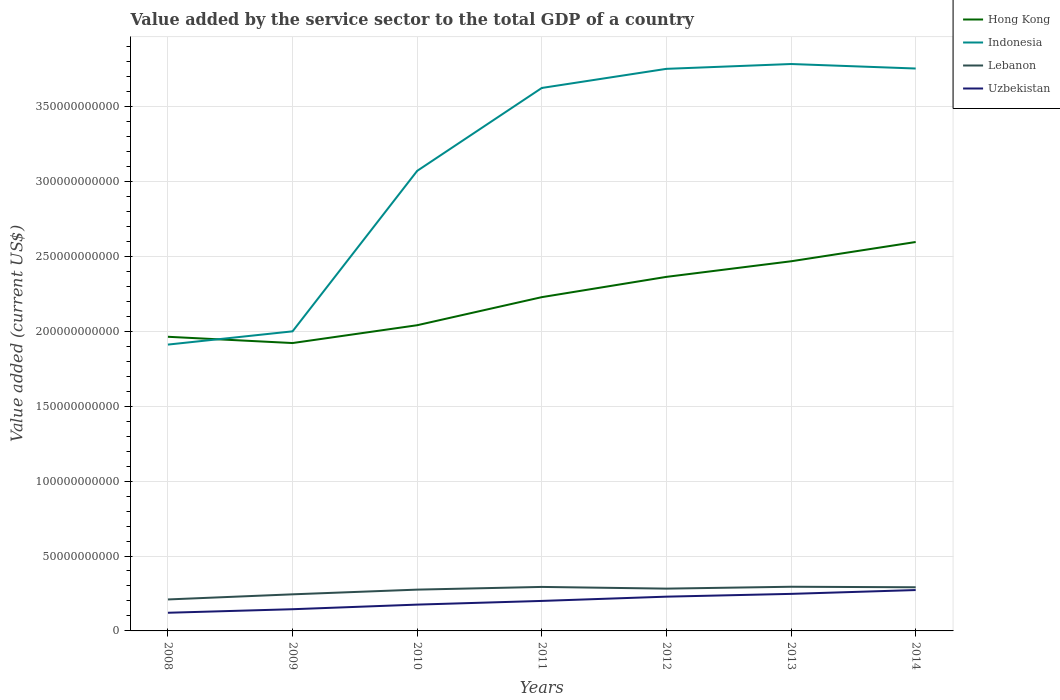Does the line corresponding to Indonesia intersect with the line corresponding to Lebanon?
Your answer should be very brief. No. Is the number of lines equal to the number of legend labels?
Your answer should be compact. Yes. Across all years, what is the maximum value added by the service sector to the total GDP in Indonesia?
Offer a terse response. 1.91e+11. In which year was the value added by the service sector to the total GDP in Lebanon maximum?
Keep it short and to the point. 2008. What is the total value added by the service sector to the total GDP in Lebanon in the graph?
Make the answer very short. -3.41e+09. What is the difference between the highest and the second highest value added by the service sector to the total GDP in Lebanon?
Your answer should be very brief. 8.47e+09. What is the difference between the highest and the lowest value added by the service sector to the total GDP in Lebanon?
Provide a succinct answer. 5. Is the value added by the service sector to the total GDP in Hong Kong strictly greater than the value added by the service sector to the total GDP in Indonesia over the years?
Your answer should be compact. No. How many years are there in the graph?
Provide a short and direct response. 7. What is the difference between two consecutive major ticks on the Y-axis?
Your response must be concise. 5.00e+1. Are the values on the major ticks of Y-axis written in scientific E-notation?
Make the answer very short. No. Does the graph contain grids?
Make the answer very short. Yes. Where does the legend appear in the graph?
Make the answer very short. Top right. How many legend labels are there?
Offer a terse response. 4. What is the title of the graph?
Ensure brevity in your answer.  Value added by the service sector to the total GDP of a country. Does "High income: nonOECD" appear as one of the legend labels in the graph?
Your answer should be very brief. No. What is the label or title of the Y-axis?
Provide a succinct answer. Value added (current US$). What is the Value added (current US$) of Hong Kong in 2008?
Offer a very short reply. 1.96e+11. What is the Value added (current US$) of Indonesia in 2008?
Keep it short and to the point. 1.91e+11. What is the Value added (current US$) in Lebanon in 2008?
Keep it short and to the point. 2.10e+1. What is the Value added (current US$) of Uzbekistan in 2008?
Provide a succinct answer. 1.21e+1. What is the Value added (current US$) of Hong Kong in 2009?
Offer a very short reply. 1.92e+11. What is the Value added (current US$) of Indonesia in 2009?
Ensure brevity in your answer.  2.00e+11. What is the Value added (current US$) in Lebanon in 2009?
Your answer should be compact. 2.44e+1. What is the Value added (current US$) in Uzbekistan in 2009?
Provide a succinct answer. 1.45e+1. What is the Value added (current US$) of Hong Kong in 2010?
Your answer should be compact. 2.04e+11. What is the Value added (current US$) of Indonesia in 2010?
Your answer should be very brief. 3.07e+11. What is the Value added (current US$) in Lebanon in 2010?
Your response must be concise. 2.76e+1. What is the Value added (current US$) of Uzbekistan in 2010?
Offer a very short reply. 1.76e+1. What is the Value added (current US$) of Hong Kong in 2011?
Your response must be concise. 2.23e+11. What is the Value added (current US$) in Indonesia in 2011?
Ensure brevity in your answer.  3.62e+11. What is the Value added (current US$) in Lebanon in 2011?
Offer a terse response. 2.94e+1. What is the Value added (current US$) in Uzbekistan in 2011?
Keep it short and to the point. 2.00e+1. What is the Value added (current US$) in Hong Kong in 2012?
Ensure brevity in your answer.  2.36e+11. What is the Value added (current US$) of Indonesia in 2012?
Keep it short and to the point. 3.75e+11. What is the Value added (current US$) of Lebanon in 2012?
Offer a very short reply. 2.82e+1. What is the Value added (current US$) in Uzbekistan in 2012?
Make the answer very short. 2.29e+1. What is the Value added (current US$) of Hong Kong in 2013?
Provide a short and direct response. 2.47e+11. What is the Value added (current US$) of Indonesia in 2013?
Ensure brevity in your answer.  3.78e+11. What is the Value added (current US$) in Lebanon in 2013?
Provide a short and direct response. 2.95e+1. What is the Value added (current US$) of Uzbekistan in 2013?
Keep it short and to the point. 2.47e+1. What is the Value added (current US$) of Hong Kong in 2014?
Your answer should be very brief. 2.60e+11. What is the Value added (current US$) in Indonesia in 2014?
Provide a short and direct response. 3.75e+11. What is the Value added (current US$) in Lebanon in 2014?
Give a very brief answer. 2.91e+1. What is the Value added (current US$) of Uzbekistan in 2014?
Make the answer very short. 2.73e+1. Across all years, what is the maximum Value added (current US$) in Hong Kong?
Provide a short and direct response. 2.60e+11. Across all years, what is the maximum Value added (current US$) of Indonesia?
Your answer should be compact. 3.78e+11. Across all years, what is the maximum Value added (current US$) of Lebanon?
Provide a succinct answer. 2.95e+1. Across all years, what is the maximum Value added (current US$) of Uzbekistan?
Your answer should be very brief. 2.73e+1. Across all years, what is the minimum Value added (current US$) in Hong Kong?
Make the answer very short. 1.92e+11. Across all years, what is the minimum Value added (current US$) of Indonesia?
Make the answer very short. 1.91e+11. Across all years, what is the minimum Value added (current US$) in Lebanon?
Offer a terse response. 2.10e+1. Across all years, what is the minimum Value added (current US$) of Uzbekistan?
Your response must be concise. 1.21e+1. What is the total Value added (current US$) of Hong Kong in the graph?
Offer a terse response. 1.56e+12. What is the total Value added (current US$) in Indonesia in the graph?
Make the answer very short. 2.19e+12. What is the total Value added (current US$) in Lebanon in the graph?
Give a very brief answer. 1.89e+11. What is the total Value added (current US$) of Uzbekistan in the graph?
Offer a terse response. 1.39e+11. What is the difference between the Value added (current US$) in Hong Kong in 2008 and that in 2009?
Provide a short and direct response. 4.19e+09. What is the difference between the Value added (current US$) of Indonesia in 2008 and that in 2009?
Keep it short and to the point. -8.84e+09. What is the difference between the Value added (current US$) of Lebanon in 2008 and that in 2009?
Your answer should be very brief. -3.41e+09. What is the difference between the Value added (current US$) in Uzbekistan in 2008 and that in 2009?
Offer a very short reply. -2.36e+09. What is the difference between the Value added (current US$) of Hong Kong in 2008 and that in 2010?
Offer a very short reply. -7.71e+09. What is the difference between the Value added (current US$) of Indonesia in 2008 and that in 2010?
Provide a short and direct response. -1.16e+11. What is the difference between the Value added (current US$) in Lebanon in 2008 and that in 2010?
Ensure brevity in your answer.  -6.55e+09. What is the difference between the Value added (current US$) of Uzbekistan in 2008 and that in 2010?
Provide a succinct answer. -5.44e+09. What is the difference between the Value added (current US$) of Hong Kong in 2008 and that in 2011?
Provide a succinct answer. -2.65e+1. What is the difference between the Value added (current US$) of Indonesia in 2008 and that in 2011?
Provide a succinct answer. -1.71e+11. What is the difference between the Value added (current US$) of Lebanon in 2008 and that in 2011?
Offer a very short reply. -8.36e+09. What is the difference between the Value added (current US$) in Uzbekistan in 2008 and that in 2011?
Ensure brevity in your answer.  -7.90e+09. What is the difference between the Value added (current US$) in Hong Kong in 2008 and that in 2012?
Offer a terse response. -4.00e+1. What is the difference between the Value added (current US$) of Indonesia in 2008 and that in 2012?
Your response must be concise. -1.84e+11. What is the difference between the Value added (current US$) in Lebanon in 2008 and that in 2012?
Offer a very short reply. -7.22e+09. What is the difference between the Value added (current US$) in Uzbekistan in 2008 and that in 2012?
Provide a succinct answer. -1.07e+1. What is the difference between the Value added (current US$) of Hong Kong in 2008 and that in 2013?
Offer a very short reply. -5.04e+1. What is the difference between the Value added (current US$) in Indonesia in 2008 and that in 2013?
Provide a succinct answer. -1.87e+11. What is the difference between the Value added (current US$) in Lebanon in 2008 and that in 2013?
Your answer should be compact. -8.47e+09. What is the difference between the Value added (current US$) in Uzbekistan in 2008 and that in 2013?
Provide a short and direct response. -1.26e+1. What is the difference between the Value added (current US$) of Hong Kong in 2008 and that in 2014?
Provide a succinct answer. -6.33e+1. What is the difference between the Value added (current US$) in Indonesia in 2008 and that in 2014?
Make the answer very short. -1.84e+11. What is the difference between the Value added (current US$) of Lebanon in 2008 and that in 2014?
Offer a terse response. -8.13e+09. What is the difference between the Value added (current US$) in Uzbekistan in 2008 and that in 2014?
Your answer should be very brief. -1.52e+1. What is the difference between the Value added (current US$) in Hong Kong in 2009 and that in 2010?
Your response must be concise. -1.19e+1. What is the difference between the Value added (current US$) in Indonesia in 2009 and that in 2010?
Offer a very short reply. -1.07e+11. What is the difference between the Value added (current US$) in Lebanon in 2009 and that in 2010?
Your response must be concise. -3.14e+09. What is the difference between the Value added (current US$) in Uzbekistan in 2009 and that in 2010?
Your answer should be compact. -3.08e+09. What is the difference between the Value added (current US$) of Hong Kong in 2009 and that in 2011?
Give a very brief answer. -3.06e+1. What is the difference between the Value added (current US$) of Indonesia in 2009 and that in 2011?
Keep it short and to the point. -1.62e+11. What is the difference between the Value added (current US$) of Lebanon in 2009 and that in 2011?
Offer a terse response. -4.95e+09. What is the difference between the Value added (current US$) in Uzbekistan in 2009 and that in 2011?
Give a very brief answer. -5.53e+09. What is the difference between the Value added (current US$) in Hong Kong in 2009 and that in 2012?
Keep it short and to the point. -4.42e+1. What is the difference between the Value added (current US$) of Indonesia in 2009 and that in 2012?
Ensure brevity in your answer.  -1.75e+11. What is the difference between the Value added (current US$) of Lebanon in 2009 and that in 2012?
Provide a short and direct response. -3.81e+09. What is the difference between the Value added (current US$) of Uzbekistan in 2009 and that in 2012?
Make the answer very short. -8.38e+09. What is the difference between the Value added (current US$) in Hong Kong in 2009 and that in 2013?
Your answer should be compact. -5.46e+1. What is the difference between the Value added (current US$) of Indonesia in 2009 and that in 2013?
Keep it short and to the point. -1.78e+11. What is the difference between the Value added (current US$) in Lebanon in 2009 and that in 2013?
Keep it short and to the point. -5.06e+09. What is the difference between the Value added (current US$) in Uzbekistan in 2009 and that in 2013?
Your answer should be very brief. -1.02e+1. What is the difference between the Value added (current US$) in Hong Kong in 2009 and that in 2014?
Provide a succinct answer. -6.74e+1. What is the difference between the Value added (current US$) in Indonesia in 2009 and that in 2014?
Make the answer very short. -1.75e+11. What is the difference between the Value added (current US$) of Lebanon in 2009 and that in 2014?
Give a very brief answer. -4.72e+09. What is the difference between the Value added (current US$) of Uzbekistan in 2009 and that in 2014?
Your answer should be very brief. -1.28e+1. What is the difference between the Value added (current US$) of Hong Kong in 2010 and that in 2011?
Your response must be concise. -1.87e+1. What is the difference between the Value added (current US$) of Indonesia in 2010 and that in 2011?
Your answer should be very brief. -5.53e+1. What is the difference between the Value added (current US$) in Lebanon in 2010 and that in 2011?
Your response must be concise. -1.81e+09. What is the difference between the Value added (current US$) of Uzbekistan in 2010 and that in 2011?
Offer a terse response. -2.45e+09. What is the difference between the Value added (current US$) of Hong Kong in 2010 and that in 2012?
Your response must be concise. -3.23e+1. What is the difference between the Value added (current US$) of Indonesia in 2010 and that in 2012?
Your answer should be very brief. -6.81e+1. What is the difference between the Value added (current US$) of Lebanon in 2010 and that in 2012?
Keep it short and to the point. -6.72e+08. What is the difference between the Value added (current US$) of Uzbekistan in 2010 and that in 2012?
Provide a short and direct response. -5.31e+09. What is the difference between the Value added (current US$) in Hong Kong in 2010 and that in 2013?
Provide a succinct answer. -4.27e+1. What is the difference between the Value added (current US$) in Indonesia in 2010 and that in 2013?
Offer a very short reply. -7.13e+1. What is the difference between the Value added (current US$) of Lebanon in 2010 and that in 2013?
Keep it short and to the point. -1.92e+09. What is the difference between the Value added (current US$) of Uzbekistan in 2010 and that in 2013?
Your answer should be very brief. -7.16e+09. What is the difference between the Value added (current US$) of Hong Kong in 2010 and that in 2014?
Offer a terse response. -5.55e+1. What is the difference between the Value added (current US$) in Indonesia in 2010 and that in 2014?
Keep it short and to the point. -6.83e+1. What is the difference between the Value added (current US$) in Lebanon in 2010 and that in 2014?
Your answer should be very brief. -1.58e+09. What is the difference between the Value added (current US$) of Uzbekistan in 2010 and that in 2014?
Your response must be concise. -9.71e+09. What is the difference between the Value added (current US$) in Hong Kong in 2011 and that in 2012?
Give a very brief answer. -1.35e+1. What is the difference between the Value added (current US$) in Indonesia in 2011 and that in 2012?
Offer a terse response. -1.28e+1. What is the difference between the Value added (current US$) of Lebanon in 2011 and that in 2012?
Provide a succinct answer. 1.14e+09. What is the difference between the Value added (current US$) in Uzbekistan in 2011 and that in 2012?
Provide a succinct answer. -2.85e+09. What is the difference between the Value added (current US$) in Hong Kong in 2011 and that in 2013?
Provide a short and direct response. -2.39e+1. What is the difference between the Value added (current US$) in Indonesia in 2011 and that in 2013?
Your answer should be very brief. -1.60e+1. What is the difference between the Value added (current US$) of Lebanon in 2011 and that in 2013?
Provide a succinct answer. -1.15e+08. What is the difference between the Value added (current US$) in Uzbekistan in 2011 and that in 2013?
Make the answer very short. -4.71e+09. What is the difference between the Value added (current US$) in Hong Kong in 2011 and that in 2014?
Offer a very short reply. -3.68e+1. What is the difference between the Value added (current US$) in Indonesia in 2011 and that in 2014?
Offer a very short reply. -1.30e+1. What is the difference between the Value added (current US$) in Lebanon in 2011 and that in 2014?
Ensure brevity in your answer.  2.27e+08. What is the difference between the Value added (current US$) in Uzbekistan in 2011 and that in 2014?
Your answer should be compact. -7.26e+09. What is the difference between the Value added (current US$) in Hong Kong in 2012 and that in 2013?
Give a very brief answer. -1.04e+1. What is the difference between the Value added (current US$) of Indonesia in 2012 and that in 2013?
Keep it short and to the point. -3.22e+09. What is the difference between the Value added (current US$) in Lebanon in 2012 and that in 2013?
Your response must be concise. -1.25e+09. What is the difference between the Value added (current US$) of Uzbekistan in 2012 and that in 2013?
Offer a terse response. -1.86e+09. What is the difference between the Value added (current US$) in Hong Kong in 2012 and that in 2014?
Your answer should be very brief. -2.33e+1. What is the difference between the Value added (current US$) in Indonesia in 2012 and that in 2014?
Keep it short and to the point. -2.11e+08. What is the difference between the Value added (current US$) in Lebanon in 2012 and that in 2014?
Your response must be concise. -9.09e+08. What is the difference between the Value added (current US$) of Uzbekistan in 2012 and that in 2014?
Your answer should be compact. -4.40e+09. What is the difference between the Value added (current US$) in Hong Kong in 2013 and that in 2014?
Ensure brevity in your answer.  -1.29e+1. What is the difference between the Value added (current US$) of Indonesia in 2013 and that in 2014?
Offer a terse response. 3.01e+09. What is the difference between the Value added (current US$) of Lebanon in 2013 and that in 2014?
Ensure brevity in your answer.  3.42e+08. What is the difference between the Value added (current US$) of Uzbekistan in 2013 and that in 2014?
Provide a succinct answer. -2.55e+09. What is the difference between the Value added (current US$) in Hong Kong in 2008 and the Value added (current US$) in Indonesia in 2009?
Provide a short and direct response. -3.63e+09. What is the difference between the Value added (current US$) in Hong Kong in 2008 and the Value added (current US$) in Lebanon in 2009?
Give a very brief answer. 1.72e+11. What is the difference between the Value added (current US$) of Hong Kong in 2008 and the Value added (current US$) of Uzbekistan in 2009?
Provide a short and direct response. 1.82e+11. What is the difference between the Value added (current US$) in Indonesia in 2008 and the Value added (current US$) in Lebanon in 2009?
Provide a succinct answer. 1.67e+11. What is the difference between the Value added (current US$) of Indonesia in 2008 and the Value added (current US$) of Uzbekistan in 2009?
Ensure brevity in your answer.  1.77e+11. What is the difference between the Value added (current US$) in Lebanon in 2008 and the Value added (current US$) in Uzbekistan in 2009?
Provide a short and direct response. 6.52e+09. What is the difference between the Value added (current US$) in Hong Kong in 2008 and the Value added (current US$) in Indonesia in 2010?
Ensure brevity in your answer.  -1.11e+11. What is the difference between the Value added (current US$) in Hong Kong in 2008 and the Value added (current US$) in Lebanon in 2010?
Make the answer very short. 1.69e+11. What is the difference between the Value added (current US$) of Hong Kong in 2008 and the Value added (current US$) of Uzbekistan in 2010?
Offer a very short reply. 1.79e+11. What is the difference between the Value added (current US$) of Indonesia in 2008 and the Value added (current US$) of Lebanon in 2010?
Provide a succinct answer. 1.64e+11. What is the difference between the Value added (current US$) of Indonesia in 2008 and the Value added (current US$) of Uzbekistan in 2010?
Offer a very short reply. 1.74e+11. What is the difference between the Value added (current US$) in Lebanon in 2008 and the Value added (current US$) in Uzbekistan in 2010?
Give a very brief answer. 3.44e+09. What is the difference between the Value added (current US$) in Hong Kong in 2008 and the Value added (current US$) in Indonesia in 2011?
Ensure brevity in your answer.  -1.66e+11. What is the difference between the Value added (current US$) in Hong Kong in 2008 and the Value added (current US$) in Lebanon in 2011?
Offer a very short reply. 1.67e+11. What is the difference between the Value added (current US$) in Hong Kong in 2008 and the Value added (current US$) in Uzbekistan in 2011?
Your response must be concise. 1.76e+11. What is the difference between the Value added (current US$) of Indonesia in 2008 and the Value added (current US$) of Lebanon in 2011?
Provide a short and direct response. 1.62e+11. What is the difference between the Value added (current US$) of Indonesia in 2008 and the Value added (current US$) of Uzbekistan in 2011?
Make the answer very short. 1.71e+11. What is the difference between the Value added (current US$) of Lebanon in 2008 and the Value added (current US$) of Uzbekistan in 2011?
Your answer should be compact. 9.89e+08. What is the difference between the Value added (current US$) of Hong Kong in 2008 and the Value added (current US$) of Indonesia in 2012?
Your response must be concise. -1.79e+11. What is the difference between the Value added (current US$) of Hong Kong in 2008 and the Value added (current US$) of Lebanon in 2012?
Make the answer very short. 1.68e+11. What is the difference between the Value added (current US$) in Hong Kong in 2008 and the Value added (current US$) in Uzbekistan in 2012?
Provide a short and direct response. 1.73e+11. What is the difference between the Value added (current US$) of Indonesia in 2008 and the Value added (current US$) of Lebanon in 2012?
Provide a short and direct response. 1.63e+11. What is the difference between the Value added (current US$) in Indonesia in 2008 and the Value added (current US$) in Uzbekistan in 2012?
Ensure brevity in your answer.  1.68e+11. What is the difference between the Value added (current US$) in Lebanon in 2008 and the Value added (current US$) in Uzbekistan in 2012?
Offer a terse response. -1.86e+09. What is the difference between the Value added (current US$) of Hong Kong in 2008 and the Value added (current US$) of Indonesia in 2013?
Provide a succinct answer. -1.82e+11. What is the difference between the Value added (current US$) of Hong Kong in 2008 and the Value added (current US$) of Lebanon in 2013?
Offer a very short reply. 1.67e+11. What is the difference between the Value added (current US$) in Hong Kong in 2008 and the Value added (current US$) in Uzbekistan in 2013?
Give a very brief answer. 1.72e+11. What is the difference between the Value added (current US$) of Indonesia in 2008 and the Value added (current US$) of Lebanon in 2013?
Your response must be concise. 1.62e+11. What is the difference between the Value added (current US$) of Indonesia in 2008 and the Value added (current US$) of Uzbekistan in 2013?
Provide a succinct answer. 1.66e+11. What is the difference between the Value added (current US$) in Lebanon in 2008 and the Value added (current US$) in Uzbekistan in 2013?
Keep it short and to the point. -3.72e+09. What is the difference between the Value added (current US$) of Hong Kong in 2008 and the Value added (current US$) of Indonesia in 2014?
Offer a terse response. -1.79e+11. What is the difference between the Value added (current US$) of Hong Kong in 2008 and the Value added (current US$) of Lebanon in 2014?
Ensure brevity in your answer.  1.67e+11. What is the difference between the Value added (current US$) in Hong Kong in 2008 and the Value added (current US$) in Uzbekistan in 2014?
Ensure brevity in your answer.  1.69e+11. What is the difference between the Value added (current US$) in Indonesia in 2008 and the Value added (current US$) in Lebanon in 2014?
Give a very brief answer. 1.62e+11. What is the difference between the Value added (current US$) in Indonesia in 2008 and the Value added (current US$) in Uzbekistan in 2014?
Make the answer very short. 1.64e+11. What is the difference between the Value added (current US$) in Lebanon in 2008 and the Value added (current US$) in Uzbekistan in 2014?
Your answer should be very brief. -6.27e+09. What is the difference between the Value added (current US$) of Hong Kong in 2009 and the Value added (current US$) of Indonesia in 2010?
Offer a very short reply. -1.15e+11. What is the difference between the Value added (current US$) in Hong Kong in 2009 and the Value added (current US$) in Lebanon in 2010?
Offer a very short reply. 1.65e+11. What is the difference between the Value added (current US$) of Hong Kong in 2009 and the Value added (current US$) of Uzbekistan in 2010?
Provide a short and direct response. 1.75e+11. What is the difference between the Value added (current US$) in Indonesia in 2009 and the Value added (current US$) in Lebanon in 2010?
Give a very brief answer. 1.72e+11. What is the difference between the Value added (current US$) of Indonesia in 2009 and the Value added (current US$) of Uzbekistan in 2010?
Your answer should be compact. 1.82e+11. What is the difference between the Value added (current US$) of Lebanon in 2009 and the Value added (current US$) of Uzbekistan in 2010?
Provide a short and direct response. 6.85e+09. What is the difference between the Value added (current US$) of Hong Kong in 2009 and the Value added (current US$) of Indonesia in 2011?
Provide a succinct answer. -1.70e+11. What is the difference between the Value added (current US$) of Hong Kong in 2009 and the Value added (current US$) of Lebanon in 2011?
Offer a terse response. 1.63e+11. What is the difference between the Value added (current US$) of Hong Kong in 2009 and the Value added (current US$) of Uzbekistan in 2011?
Your answer should be compact. 1.72e+11. What is the difference between the Value added (current US$) in Indonesia in 2009 and the Value added (current US$) in Lebanon in 2011?
Provide a succinct answer. 1.71e+11. What is the difference between the Value added (current US$) in Indonesia in 2009 and the Value added (current US$) in Uzbekistan in 2011?
Your answer should be compact. 1.80e+11. What is the difference between the Value added (current US$) of Lebanon in 2009 and the Value added (current US$) of Uzbekistan in 2011?
Your response must be concise. 4.40e+09. What is the difference between the Value added (current US$) of Hong Kong in 2009 and the Value added (current US$) of Indonesia in 2012?
Provide a short and direct response. -1.83e+11. What is the difference between the Value added (current US$) in Hong Kong in 2009 and the Value added (current US$) in Lebanon in 2012?
Your response must be concise. 1.64e+11. What is the difference between the Value added (current US$) of Hong Kong in 2009 and the Value added (current US$) of Uzbekistan in 2012?
Offer a very short reply. 1.69e+11. What is the difference between the Value added (current US$) of Indonesia in 2009 and the Value added (current US$) of Lebanon in 2012?
Ensure brevity in your answer.  1.72e+11. What is the difference between the Value added (current US$) in Indonesia in 2009 and the Value added (current US$) in Uzbekistan in 2012?
Keep it short and to the point. 1.77e+11. What is the difference between the Value added (current US$) of Lebanon in 2009 and the Value added (current US$) of Uzbekistan in 2012?
Your answer should be compact. 1.55e+09. What is the difference between the Value added (current US$) of Hong Kong in 2009 and the Value added (current US$) of Indonesia in 2013?
Your response must be concise. -1.86e+11. What is the difference between the Value added (current US$) in Hong Kong in 2009 and the Value added (current US$) in Lebanon in 2013?
Your response must be concise. 1.63e+11. What is the difference between the Value added (current US$) in Hong Kong in 2009 and the Value added (current US$) in Uzbekistan in 2013?
Make the answer very short. 1.67e+11. What is the difference between the Value added (current US$) in Indonesia in 2009 and the Value added (current US$) in Lebanon in 2013?
Your answer should be compact. 1.70e+11. What is the difference between the Value added (current US$) of Indonesia in 2009 and the Value added (current US$) of Uzbekistan in 2013?
Provide a short and direct response. 1.75e+11. What is the difference between the Value added (current US$) in Lebanon in 2009 and the Value added (current US$) in Uzbekistan in 2013?
Give a very brief answer. -3.09e+08. What is the difference between the Value added (current US$) in Hong Kong in 2009 and the Value added (current US$) in Indonesia in 2014?
Offer a very short reply. -1.83e+11. What is the difference between the Value added (current US$) of Hong Kong in 2009 and the Value added (current US$) of Lebanon in 2014?
Give a very brief answer. 1.63e+11. What is the difference between the Value added (current US$) in Hong Kong in 2009 and the Value added (current US$) in Uzbekistan in 2014?
Your response must be concise. 1.65e+11. What is the difference between the Value added (current US$) in Indonesia in 2009 and the Value added (current US$) in Lebanon in 2014?
Give a very brief answer. 1.71e+11. What is the difference between the Value added (current US$) of Indonesia in 2009 and the Value added (current US$) of Uzbekistan in 2014?
Keep it short and to the point. 1.73e+11. What is the difference between the Value added (current US$) in Lebanon in 2009 and the Value added (current US$) in Uzbekistan in 2014?
Your answer should be very brief. -2.86e+09. What is the difference between the Value added (current US$) in Hong Kong in 2010 and the Value added (current US$) in Indonesia in 2011?
Provide a short and direct response. -1.58e+11. What is the difference between the Value added (current US$) in Hong Kong in 2010 and the Value added (current US$) in Lebanon in 2011?
Keep it short and to the point. 1.75e+11. What is the difference between the Value added (current US$) of Hong Kong in 2010 and the Value added (current US$) of Uzbekistan in 2011?
Offer a terse response. 1.84e+11. What is the difference between the Value added (current US$) of Indonesia in 2010 and the Value added (current US$) of Lebanon in 2011?
Give a very brief answer. 2.78e+11. What is the difference between the Value added (current US$) of Indonesia in 2010 and the Value added (current US$) of Uzbekistan in 2011?
Provide a short and direct response. 2.87e+11. What is the difference between the Value added (current US$) of Lebanon in 2010 and the Value added (current US$) of Uzbekistan in 2011?
Keep it short and to the point. 7.54e+09. What is the difference between the Value added (current US$) of Hong Kong in 2010 and the Value added (current US$) of Indonesia in 2012?
Provide a succinct answer. -1.71e+11. What is the difference between the Value added (current US$) in Hong Kong in 2010 and the Value added (current US$) in Lebanon in 2012?
Provide a succinct answer. 1.76e+11. What is the difference between the Value added (current US$) of Hong Kong in 2010 and the Value added (current US$) of Uzbekistan in 2012?
Your response must be concise. 1.81e+11. What is the difference between the Value added (current US$) of Indonesia in 2010 and the Value added (current US$) of Lebanon in 2012?
Provide a succinct answer. 2.79e+11. What is the difference between the Value added (current US$) in Indonesia in 2010 and the Value added (current US$) in Uzbekistan in 2012?
Make the answer very short. 2.84e+11. What is the difference between the Value added (current US$) in Lebanon in 2010 and the Value added (current US$) in Uzbekistan in 2012?
Your answer should be very brief. 4.69e+09. What is the difference between the Value added (current US$) in Hong Kong in 2010 and the Value added (current US$) in Indonesia in 2013?
Provide a succinct answer. -1.74e+11. What is the difference between the Value added (current US$) in Hong Kong in 2010 and the Value added (current US$) in Lebanon in 2013?
Offer a terse response. 1.75e+11. What is the difference between the Value added (current US$) of Hong Kong in 2010 and the Value added (current US$) of Uzbekistan in 2013?
Make the answer very short. 1.79e+11. What is the difference between the Value added (current US$) in Indonesia in 2010 and the Value added (current US$) in Lebanon in 2013?
Make the answer very short. 2.78e+11. What is the difference between the Value added (current US$) in Indonesia in 2010 and the Value added (current US$) in Uzbekistan in 2013?
Your answer should be very brief. 2.82e+11. What is the difference between the Value added (current US$) in Lebanon in 2010 and the Value added (current US$) in Uzbekistan in 2013?
Make the answer very short. 2.83e+09. What is the difference between the Value added (current US$) of Hong Kong in 2010 and the Value added (current US$) of Indonesia in 2014?
Keep it short and to the point. -1.71e+11. What is the difference between the Value added (current US$) of Hong Kong in 2010 and the Value added (current US$) of Lebanon in 2014?
Ensure brevity in your answer.  1.75e+11. What is the difference between the Value added (current US$) of Hong Kong in 2010 and the Value added (current US$) of Uzbekistan in 2014?
Your answer should be very brief. 1.77e+11. What is the difference between the Value added (current US$) in Indonesia in 2010 and the Value added (current US$) in Lebanon in 2014?
Give a very brief answer. 2.78e+11. What is the difference between the Value added (current US$) in Indonesia in 2010 and the Value added (current US$) in Uzbekistan in 2014?
Your answer should be very brief. 2.80e+11. What is the difference between the Value added (current US$) of Lebanon in 2010 and the Value added (current US$) of Uzbekistan in 2014?
Make the answer very short. 2.83e+08. What is the difference between the Value added (current US$) in Hong Kong in 2011 and the Value added (current US$) in Indonesia in 2012?
Provide a succinct answer. -1.52e+11. What is the difference between the Value added (current US$) of Hong Kong in 2011 and the Value added (current US$) of Lebanon in 2012?
Offer a terse response. 1.95e+11. What is the difference between the Value added (current US$) in Hong Kong in 2011 and the Value added (current US$) in Uzbekistan in 2012?
Keep it short and to the point. 2.00e+11. What is the difference between the Value added (current US$) of Indonesia in 2011 and the Value added (current US$) of Lebanon in 2012?
Offer a very short reply. 3.34e+11. What is the difference between the Value added (current US$) in Indonesia in 2011 and the Value added (current US$) in Uzbekistan in 2012?
Offer a very short reply. 3.40e+11. What is the difference between the Value added (current US$) of Lebanon in 2011 and the Value added (current US$) of Uzbekistan in 2012?
Your answer should be very brief. 6.50e+09. What is the difference between the Value added (current US$) in Hong Kong in 2011 and the Value added (current US$) in Indonesia in 2013?
Your answer should be very brief. -1.56e+11. What is the difference between the Value added (current US$) of Hong Kong in 2011 and the Value added (current US$) of Lebanon in 2013?
Offer a very short reply. 1.93e+11. What is the difference between the Value added (current US$) in Hong Kong in 2011 and the Value added (current US$) in Uzbekistan in 2013?
Give a very brief answer. 1.98e+11. What is the difference between the Value added (current US$) of Indonesia in 2011 and the Value added (current US$) of Lebanon in 2013?
Your response must be concise. 3.33e+11. What is the difference between the Value added (current US$) of Indonesia in 2011 and the Value added (current US$) of Uzbekistan in 2013?
Provide a short and direct response. 3.38e+11. What is the difference between the Value added (current US$) of Lebanon in 2011 and the Value added (current US$) of Uzbekistan in 2013?
Provide a short and direct response. 4.64e+09. What is the difference between the Value added (current US$) in Hong Kong in 2011 and the Value added (current US$) in Indonesia in 2014?
Your answer should be very brief. -1.53e+11. What is the difference between the Value added (current US$) of Hong Kong in 2011 and the Value added (current US$) of Lebanon in 2014?
Ensure brevity in your answer.  1.94e+11. What is the difference between the Value added (current US$) in Hong Kong in 2011 and the Value added (current US$) in Uzbekistan in 2014?
Provide a succinct answer. 1.96e+11. What is the difference between the Value added (current US$) in Indonesia in 2011 and the Value added (current US$) in Lebanon in 2014?
Your answer should be very brief. 3.33e+11. What is the difference between the Value added (current US$) in Indonesia in 2011 and the Value added (current US$) in Uzbekistan in 2014?
Offer a terse response. 3.35e+11. What is the difference between the Value added (current US$) of Lebanon in 2011 and the Value added (current US$) of Uzbekistan in 2014?
Offer a very short reply. 2.09e+09. What is the difference between the Value added (current US$) of Hong Kong in 2012 and the Value added (current US$) of Indonesia in 2013?
Ensure brevity in your answer.  -1.42e+11. What is the difference between the Value added (current US$) in Hong Kong in 2012 and the Value added (current US$) in Lebanon in 2013?
Keep it short and to the point. 2.07e+11. What is the difference between the Value added (current US$) of Hong Kong in 2012 and the Value added (current US$) of Uzbekistan in 2013?
Offer a terse response. 2.12e+11. What is the difference between the Value added (current US$) of Indonesia in 2012 and the Value added (current US$) of Lebanon in 2013?
Your answer should be very brief. 3.46e+11. What is the difference between the Value added (current US$) of Indonesia in 2012 and the Value added (current US$) of Uzbekistan in 2013?
Ensure brevity in your answer.  3.50e+11. What is the difference between the Value added (current US$) of Lebanon in 2012 and the Value added (current US$) of Uzbekistan in 2013?
Your answer should be very brief. 3.50e+09. What is the difference between the Value added (current US$) of Hong Kong in 2012 and the Value added (current US$) of Indonesia in 2014?
Offer a terse response. -1.39e+11. What is the difference between the Value added (current US$) in Hong Kong in 2012 and the Value added (current US$) in Lebanon in 2014?
Provide a short and direct response. 2.07e+11. What is the difference between the Value added (current US$) in Hong Kong in 2012 and the Value added (current US$) in Uzbekistan in 2014?
Make the answer very short. 2.09e+11. What is the difference between the Value added (current US$) of Indonesia in 2012 and the Value added (current US$) of Lebanon in 2014?
Give a very brief answer. 3.46e+11. What is the difference between the Value added (current US$) in Indonesia in 2012 and the Value added (current US$) in Uzbekistan in 2014?
Offer a terse response. 3.48e+11. What is the difference between the Value added (current US$) in Lebanon in 2012 and the Value added (current US$) in Uzbekistan in 2014?
Ensure brevity in your answer.  9.55e+08. What is the difference between the Value added (current US$) in Hong Kong in 2013 and the Value added (current US$) in Indonesia in 2014?
Your answer should be very brief. -1.29e+11. What is the difference between the Value added (current US$) of Hong Kong in 2013 and the Value added (current US$) of Lebanon in 2014?
Your response must be concise. 2.18e+11. What is the difference between the Value added (current US$) of Hong Kong in 2013 and the Value added (current US$) of Uzbekistan in 2014?
Your response must be concise. 2.19e+11. What is the difference between the Value added (current US$) in Indonesia in 2013 and the Value added (current US$) in Lebanon in 2014?
Your answer should be very brief. 3.49e+11. What is the difference between the Value added (current US$) of Indonesia in 2013 and the Value added (current US$) of Uzbekistan in 2014?
Ensure brevity in your answer.  3.51e+11. What is the difference between the Value added (current US$) of Lebanon in 2013 and the Value added (current US$) of Uzbekistan in 2014?
Offer a very short reply. 2.21e+09. What is the average Value added (current US$) of Hong Kong per year?
Keep it short and to the point. 2.23e+11. What is the average Value added (current US$) of Indonesia per year?
Provide a short and direct response. 3.13e+11. What is the average Value added (current US$) of Lebanon per year?
Your answer should be very brief. 2.70e+1. What is the average Value added (current US$) of Uzbekistan per year?
Provide a short and direct response. 1.99e+1. In the year 2008, what is the difference between the Value added (current US$) of Hong Kong and Value added (current US$) of Indonesia?
Make the answer very short. 5.21e+09. In the year 2008, what is the difference between the Value added (current US$) in Hong Kong and Value added (current US$) in Lebanon?
Make the answer very short. 1.75e+11. In the year 2008, what is the difference between the Value added (current US$) in Hong Kong and Value added (current US$) in Uzbekistan?
Offer a terse response. 1.84e+11. In the year 2008, what is the difference between the Value added (current US$) of Indonesia and Value added (current US$) of Lebanon?
Your answer should be compact. 1.70e+11. In the year 2008, what is the difference between the Value added (current US$) of Indonesia and Value added (current US$) of Uzbekistan?
Keep it short and to the point. 1.79e+11. In the year 2008, what is the difference between the Value added (current US$) in Lebanon and Value added (current US$) in Uzbekistan?
Ensure brevity in your answer.  8.89e+09. In the year 2009, what is the difference between the Value added (current US$) of Hong Kong and Value added (current US$) of Indonesia?
Your answer should be compact. -7.81e+09. In the year 2009, what is the difference between the Value added (current US$) of Hong Kong and Value added (current US$) of Lebanon?
Give a very brief answer. 1.68e+11. In the year 2009, what is the difference between the Value added (current US$) in Hong Kong and Value added (current US$) in Uzbekistan?
Ensure brevity in your answer.  1.78e+11. In the year 2009, what is the difference between the Value added (current US$) in Indonesia and Value added (current US$) in Lebanon?
Your answer should be very brief. 1.76e+11. In the year 2009, what is the difference between the Value added (current US$) in Indonesia and Value added (current US$) in Uzbekistan?
Make the answer very short. 1.85e+11. In the year 2009, what is the difference between the Value added (current US$) in Lebanon and Value added (current US$) in Uzbekistan?
Your answer should be compact. 9.93e+09. In the year 2010, what is the difference between the Value added (current US$) of Hong Kong and Value added (current US$) of Indonesia?
Provide a succinct answer. -1.03e+11. In the year 2010, what is the difference between the Value added (current US$) of Hong Kong and Value added (current US$) of Lebanon?
Your answer should be very brief. 1.76e+11. In the year 2010, what is the difference between the Value added (current US$) in Hong Kong and Value added (current US$) in Uzbekistan?
Give a very brief answer. 1.86e+11. In the year 2010, what is the difference between the Value added (current US$) of Indonesia and Value added (current US$) of Lebanon?
Your answer should be compact. 2.80e+11. In the year 2010, what is the difference between the Value added (current US$) of Indonesia and Value added (current US$) of Uzbekistan?
Your answer should be compact. 2.89e+11. In the year 2010, what is the difference between the Value added (current US$) of Lebanon and Value added (current US$) of Uzbekistan?
Make the answer very short. 9.99e+09. In the year 2011, what is the difference between the Value added (current US$) in Hong Kong and Value added (current US$) in Indonesia?
Your response must be concise. -1.40e+11. In the year 2011, what is the difference between the Value added (current US$) of Hong Kong and Value added (current US$) of Lebanon?
Offer a terse response. 1.93e+11. In the year 2011, what is the difference between the Value added (current US$) of Hong Kong and Value added (current US$) of Uzbekistan?
Your response must be concise. 2.03e+11. In the year 2011, what is the difference between the Value added (current US$) in Indonesia and Value added (current US$) in Lebanon?
Make the answer very short. 3.33e+11. In the year 2011, what is the difference between the Value added (current US$) of Indonesia and Value added (current US$) of Uzbekistan?
Offer a very short reply. 3.42e+11. In the year 2011, what is the difference between the Value added (current US$) of Lebanon and Value added (current US$) of Uzbekistan?
Your answer should be very brief. 9.35e+09. In the year 2012, what is the difference between the Value added (current US$) of Hong Kong and Value added (current US$) of Indonesia?
Keep it short and to the point. -1.39e+11. In the year 2012, what is the difference between the Value added (current US$) of Hong Kong and Value added (current US$) of Lebanon?
Your answer should be very brief. 2.08e+11. In the year 2012, what is the difference between the Value added (current US$) of Hong Kong and Value added (current US$) of Uzbekistan?
Keep it short and to the point. 2.13e+11. In the year 2012, what is the difference between the Value added (current US$) of Indonesia and Value added (current US$) of Lebanon?
Keep it short and to the point. 3.47e+11. In the year 2012, what is the difference between the Value added (current US$) in Indonesia and Value added (current US$) in Uzbekistan?
Your answer should be very brief. 3.52e+11. In the year 2012, what is the difference between the Value added (current US$) of Lebanon and Value added (current US$) of Uzbekistan?
Offer a very short reply. 5.36e+09. In the year 2013, what is the difference between the Value added (current US$) of Hong Kong and Value added (current US$) of Indonesia?
Provide a short and direct response. -1.32e+11. In the year 2013, what is the difference between the Value added (current US$) of Hong Kong and Value added (current US$) of Lebanon?
Ensure brevity in your answer.  2.17e+11. In the year 2013, what is the difference between the Value added (current US$) in Hong Kong and Value added (current US$) in Uzbekistan?
Your response must be concise. 2.22e+11. In the year 2013, what is the difference between the Value added (current US$) in Indonesia and Value added (current US$) in Lebanon?
Ensure brevity in your answer.  3.49e+11. In the year 2013, what is the difference between the Value added (current US$) in Indonesia and Value added (current US$) in Uzbekistan?
Your answer should be very brief. 3.54e+11. In the year 2013, what is the difference between the Value added (current US$) of Lebanon and Value added (current US$) of Uzbekistan?
Your answer should be compact. 4.75e+09. In the year 2014, what is the difference between the Value added (current US$) of Hong Kong and Value added (current US$) of Indonesia?
Keep it short and to the point. -1.16e+11. In the year 2014, what is the difference between the Value added (current US$) in Hong Kong and Value added (current US$) in Lebanon?
Ensure brevity in your answer.  2.30e+11. In the year 2014, what is the difference between the Value added (current US$) in Hong Kong and Value added (current US$) in Uzbekistan?
Your response must be concise. 2.32e+11. In the year 2014, what is the difference between the Value added (current US$) of Indonesia and Value added (current US$) of Lebanon?
Offer a terse response. 3.46e+11. In the year 2014, what is the difference between the Value added (current US$) in Indonesia and Value added (current US$) in Uzbekistan?
Keep it short and to the point. 3.48e+11. In the year 2014, what is the difference between the Value added (current US$) of Lebanon and Value added (current US$) of Uzbekistan?
Your answer should be compact. 1.86e+09. What is the ratio of the Value added (current US$) in Hong Kong in 2008 to that in 2009?
Give a very brief answer. 1.02. What is the ratio of the Value added (current US$) in Indonesia in 2008 to that in 2009?
Provide a short and direct response. 0.96. What is the ratio of the Value added (current US$) of Lebanon in 2008 to that in 2009?
Give a very brief answer. 0.86. What is the ratio of the Value added (current US$) in Uzbekistan in 2008 to that in 2009?
Offer a very short reply. 0.84. What is the ratio of the Value added (current US$) of Hong Kong in 2008 to that in 2010?
Keep it short and to the point. 0.96. What is the ratio of the Value added (current US$) of Indonesia in 2008 to that in 2010?
Your response must be concise. 0.62. What is the ratio of the Value added (current US$) in Lebanon in 2008 to that in 2010?
Your answer should be very brief. 0.76. What is the ratio of the Value added (current US$) in Uzbekistan in 2008 to that in 2010?
Provide a succinct answer. 0.69. What is the ratio of the Value added (current US$) in Hong Kong in 2008 to that in 2011?
Offer a terse response. 0.88. What is the ratio of the Value added (current US$) of Indonesia in 2008 to that in 2011?
Your answer should be very brief. 0.53. What is the ratio of the Value added (current US$) in Lebanon in 2008 to that in 2011?
Your answer should be very brief. 0.72. What is the ratio of the Value added (current US$) in Uzbekistan in 2008 to that in 2011?
Provide a succinct answer. 0.61. What is the ratio of the Value added (current US$) of Hong Kong in 2008 to that in 2012?
Your answer should be compact. 0.83. What is the ratio of the Value added (current US$) of Indonesia in 2008 to that in 2012?
Offer a terse response. 0.51. What is the ratio of the Value added (current US$) in Lebanon in 2008 to that in 2012?
Make the answer very short. 0.74. What is the ratio of the Value added (current US$) of Uzbekistan in 2008 to that in 2012?
Keep it short and to the point. 0.53. What is the ratio of the Value added (current US$) of Hong Kong in 2008 to that in 2013?
Your response must be concise. 0.8. What is the ratio of the Value added (current US$) in Indonesia in 2008 to that in 2013?
Give a very brief answer. 0.51. What is the ratio of the Value added (current US$) in Lebanon in 2008 to that in 2013?
Keep it short and to the point. 0.71. What is the ratio of the Value added (current US$) of Uzbekistan in 2008 to that in 2013?
Offer a terse response. 0.49. What is the ratio of the Value added (current US$) of Hong Kong in 2008 to that in 2014?
Keep it short and to the point. 0.76. What is the ratio of the Value added (current US$) of Indonesia in 2008 to that in 2014?
Your answer should be very brief. 0.51. What is the ratio of the Value added (current US$) of Lebanon in 2008 to that in 2014?
Offer a terse response. 0.72. What is the ratio of the Value added (current US$) of Uzbekistan in 2008 to that in 2014?
Make the answer very short. 0.44. What is the ratio of the Value added (current US$) of Hong Kong in 2009 to that in 2010?
Offer a terse response. 0.94. What is the ratio of the Value added (current US$) of Indonesia in 2009 to that in 2010?
Offer a terse response. 0.65. What is the ratio of the Value added (current US$) of Lebanon in 2009 to that in 2010?
Make the answer very short. 0.89. What is the ratio of the Value added (current US$) of Uzbekistan in 2009 to that in 2010?
Give a very brief answer. 0.82. What is the ratio of the Value added (current US$) in Hong Kong in 2009 to that in 2011?
Your answer should be compact. 0.86. What is the ratio of the Value added (current US$) of Indonesia in 2009 to that in 2011?
Your answer should be very brief. 0.55. What is the ratio of the Value added (current US$) of Lebanon in 2009 to that in 2011?
Your answer should be very brief. 0.83. What is the ratio of the Value added (current US$) in Uzbekistan in 2009 to that in 2011?
Your answer should be compact. 0.72. What is the ratio of the Value added (current US$) in Hong Kong in 2009 to that in 2012?
Your answer should be compact. 0.81. What is the ratio of the Value added (current US$) of Indonesia in 2009 to that in 2012?
Ensure brevity in your answer.  0.53. What is the ratio of the Value added (current US$) in Lebanon in 2009 to that in 2012?
Provide a succinct answer. 0.86. What is the ratio of the Value added (current US$) of Uzbekistan in 2009 to that in 2012?
Offer a very short reply. 0.63. What is the ratio of the Value added (current US$) of Hong Kong in 2009 to that in 2013?
Offer a very short reply. 0.78. What is the ratio of the Value added (current US$) in Indonesia in 2009 to that in 2013?
Give a very brief answer. 0.53. What is the ratio of the Value added (current US$) in Lebanon in 2009 to that in 2013?
Your response must be concise. 0.83. What is the ratio of the Value added (current US$) of Uzbekistan in 2009 to that in 2013?
Your response must be concise. 0.59. What is the ratio of the Value added (current US$) of Hong Kong in 2009 to that in 2014?
Ensure brevity in your answer.  0.74. What is the ratio of the Value added (current US$) in Indonesia in 2009 to that in 2014?
Offer a very short reply. 0.53. What is the ratio of the Value added (current US$) in Lebanon in 2009 to that in 2014?
Keep it short and to the point. 0.84. What is the ratio of the Value added (current US$) of Uzbekistan in 2009 to that in 2014?
Your response must be concise. 0.53. What is the ratio of the Value added (current US$) in Hong Kong in 2010 to that in 2011?
Give a very brief answer. 0.92. What is the ratio of the Value added (current US$) of Indonesia in 2010 to that in 2011?
Give a very brief answer. 0.85. What is the ratio of the Value added (current US$) in Lebanon in 2010 to that in 2011?
Offer a very short reply. 0.94. What is the ratio of the Value added (current US$) in Uzbekistan in 2010 to that in 2011?
Offer a very short reply. 0.88. What is the ratio of the Value added (current US$) in Hong Kong in 2010 to that in 2012?
Provide a short and direct response. 0.86. What is the ratio of the Value added (current US$) of Indonesia in 2010 to that in 2012?
Make the answer very short. 0.82. What is the ratio of the Value added (current US$) in Lebanon in 2010 to that in 2012?
Offer a very short reply. 0.98. What is the ratio of the Value added (current US$) in Uzbekistan in 2010 to that in 2012?
Give a very brief answer. 0.77. What is the ratio of the Value added (current US$) of Hong Kong in 2010 to that in 2013?
Make the answer very short. 0.83. What is the ratio of the Value added (current US$) in Indonesia in 2010 to that in 2013?
Offer a terse response. 0.81. What is the ratio of the Value added (current US$) of Lebanon in 2010 to that in 2013?
Give a very brief answer. 0.93. What is the ratio of the Value added (current US$) in Uzbekistan in 2010 to that in 2013?
Make the answer very short. 0.71. What is the ratio of the Value added (current US$) of Hong Kong in 2010 to that in 2014?
Provide a succinct answer. 0.79. What is the ratio of the Value added (current US$) of Indonesia in 2010 to that in 2014?
Your answer should be compact. 0.82. What is the ratio of the Value added (current US$) in Lebanon in 2010 to that in 2014?
Make the answer very short. 0.95. What is the ratio of the Value added (current US$) in Uzbekistan in 2010 to that in 2014?
Offer a terse response. 0.64. What is the ratio of the Value added (current US$) in Hong Kong in 2011 to that in 2012?
Your answer should be very brief. 0.94. What is the ratio of the Value added (current US$) of Lebanon in 2011 to that in 2012?
Your response must be concise. 1.04. What is the ratio of the Value added (current US$) of Uzbekistan in 2011 to that in 2012?
Provide a short and direct response. 0.88. What is the ratio of the Value added (current US$) in Hong Kong in 2011 to that in 2013?
Your response must be concise. 0.9. What is the ratio of the Value added (current US$) of Indonesia in 2011 to that in 2013?
Ensure brevity in your answer.  0.96. What is the ratio of the Value added (current US$) in Uzbekistan in 2011 to that in 2013?
Provide a succinct answer. 0.81. What is the ratio of the Value added (current US$) of Hong Kong in 2011 to that in 2014?
Provide a short and direct response. 0.86. What is the ratio of the Value added (current US$) in Indonesia in 2011 to that in 2014?
Ensure brevity in your answer.  0.97. What is the ratio of the Value added (current US$) in Lebanon in 2011 to that in 2014?
Provide a succinct answer. 1.01. What is the ratio of the Value added (current US$) of Uzbekistan in 2011 to that in 2014?
Provide a short and direct response. 0.73. What is the ratio of the Value added (current US$) of Hong Kong in 2012 to that in 2013?
Your answer should be very brief. 0.96. What is the ratio of the Value added (current US$) of Indonesia in 2012 to that in 2013?
Provide a short and direct response. 0.99. What is the ratio of the Value added (current US$) in Lebanon in 2012 to that in 2013?
Offer a very short reply. 0.96. What is the ratio of the Value added (current US$) in Uzbekistan in 2012 to that in 2013?
Ensure brevity in your answer.  0.92. What is the ratio of the Value added (current US$) of Hong Kong in 2012 to that in 2014?
Offer a terse response. 0.91. What is the ratio of the Value added (current US$) of Lebanon in 2012 to that in 2014?
Your answer should be very brief. 0.97. What is the ratio of the Value added (current US$) in Uzbekistan in 2012 to that in 2014?
Offer a terse response. 0.84. What is the ratio of the Value added (current US$) in Hong Kong in 2013 to that in 2014?
Your answer should be compact. 0.95. What is the ratio of the Value added (current US$) of Indonesia in 2013 to that in 2014?
Give a very brief answer. 1.01. What is the ratio of the Value added (current US$) in Lebanon in 2013 to that in 2014?
Your response must be concise. 1.01. What is the ratio of the Value added (current US$) of Uzbekistan in 2013 to that in 2014?
Make the answer very short. 0.91. What is the difference between the highest and the second highest Value added (current US$) of Hong Kong?
Provide a short and direct response. 1.29e+1. What is the difference between the highest and the second highest Value added (current US$) in Indonesia?
Your answer should be compact. 3.01e+09. What is the difference between the highest and the second highest Value added (current US$) in Lebanon?
Offer a very short reply. 1.15e+08. What is the difference between the highest and the second highest Value added (current US$) of Uzbekistan?
Keep it short and to the point. 2.55e+09. What is the difference between the highest and the lowest Value added (current US$) in Hong Kong?
Offer a terse response. 6.74e+1. What is the difference between the highest and the lowest Value added (current US$) of Indonesia?
Provide a succinct answer. 1.87e+11. What is the difference between the highest and the lowest Value added (current US$) in Lebanon?
Your answer should be compact. 8.47e+09. What is the difference between the highest and the lowest Value added (current US$) in Uzbekistan?
Your answer should be compact. 1.52e+1. 